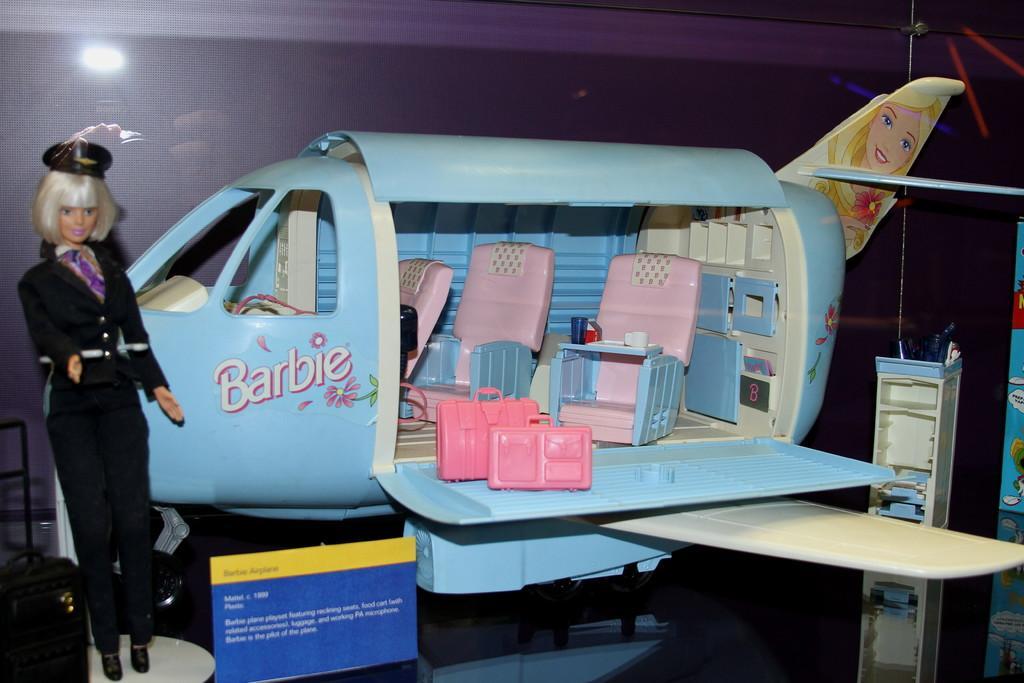In one or two sentences, can you explain what this image depicts? In the picture I can see an airplane toy on the floor. I can see the plastic chairs in the airplane. I can see a baby doll on the left side. 